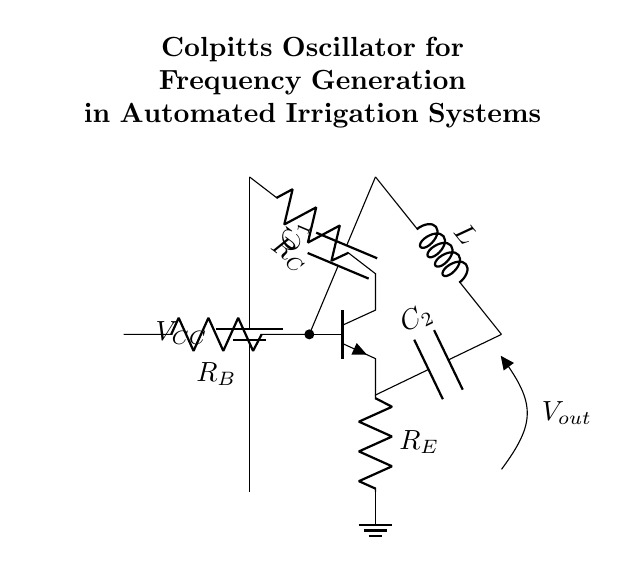What is the main component used for frequency generation in this circuit? The main component for frequency generation in a Colpitts oscillator is the combination of the inductor and capacitors. In this diagram, the inductor is labeled L and is connected in the feedback loop with capacitors C1 and C2, which help determine the frequency of oscillation.
Answer: Combination of inductor and capacitors What type of transistor is used in the circuit? The circuit uses an NPN transistor, indicated by the npn label in the diagram. It is essential in providing the necessary gain for the oscillator to function and to maintain oscillations through feedback.
Answer: NPN transistor What is the role of resistor R_E in the circuit? Resistor R_E serves as the emitter resistor, which helps stabilize the biasing conditions of the transistor. This stabilization is crucial in maintaining consistent oscillation and preventing distortion in the output signal.
Answer: Stabilizing biasing What are the voltage values labeled in the circuit? The voltage value labeled is V_CC, which is the supply voltage for the circuit. This power supply voltage is crucial for the operation of the transistor and the overall oscillator functionality.
Answer: V_CC How does the output voltage relate to the frequency generated? The output voltage, denoted as V_out in the circuit, is directly proportional to the frequency of oscillation determined by the values of L and the capacitors C1 and C2. As the frequency increases, the oscillator generates a higher output voltage signal.
Answer: Proportional to frequency What components determine the frequency of the Colpitts oscillator? The frequency of the Colpitts oscillator is determined by the inductance of L and the capacitances of C1 and C2. Their values are key to calculating the oscillation frequency via the formula: frequency = 1/(2π√(L(C1*C2/(C1+C2)))).
Answer: Inductor L, capacitors C1 and C2 What is the function of capacitor C1 in the circuit? Capacitor C1 functions as a part of the feedback network in the oscillator, helping to shape the frequency response. It, along with C2, influences the oscillation frequency and stability by controlling the feedback ratio in the circuit.
Answer: Feedback network component 